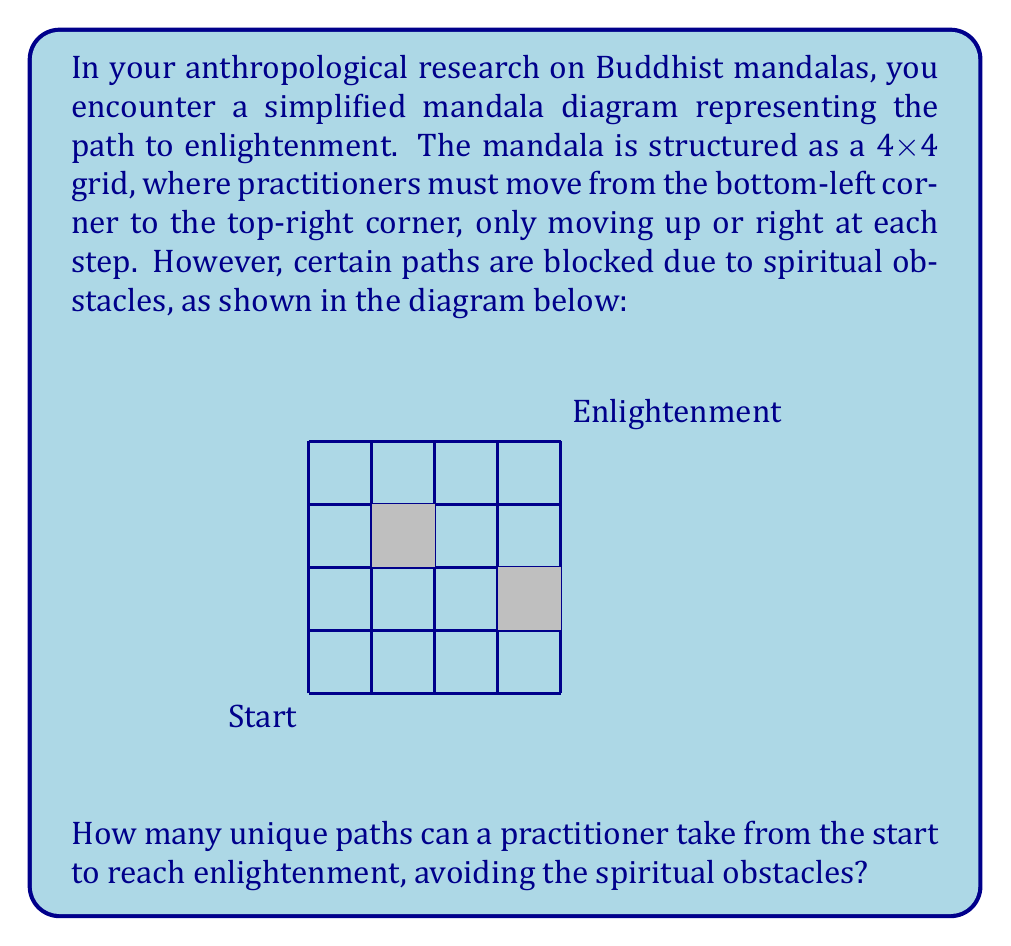Show me your answer to this math problem. To solve this problem, we'll use a combination of the path-counting principle and dynamic programming. Let's break it down step-by-step:

1) First, let's create a 5x5 grid (to include the start and end points) and label each cell with the number of ways to reach it. We'll update these numbers as we go.

2) Initialize the first row and column with 1's, except where blocked:
   $$\begin{matrix}
   1 & 1 & 1 & 1 & 1 \\
   1 & 1 & 1 & 1 & 0 \\
   1 & 1 & 0 & 1 & 1 \\
   1 & 1 & 1 & 1 & 1 \\
   1 & 0 & 0 & 0 & ?
   \end{matrix}$$

3) Now, we'll fill in the rest of the grid. For each cell, the number of ways to reach it is the sum of the ways to reach the cell to its left and the cell below it, unless it's blocked:

   $$\begin{matrix}
   1 & 1 & 1 & 1 & 1 \\
   1 & 2 & 3 & 4 & 0 \\
   1 & 3 & 0 & 4 & 4 \\
   1 & 4 & 4 & 8 & 12 \\
   1 & 0 & 0 & 0 & 20
   \end{matrix}$$

4) The number in the top-right corner (20) represents the total number of unique paths from start to enlightenment.

This approach is based on the principle that to reach any given point, you can only come from the left or from below, and the number of ways to reach that point is the sum of the ways to reach those two preceding points.
Answer: 20 unique paths 